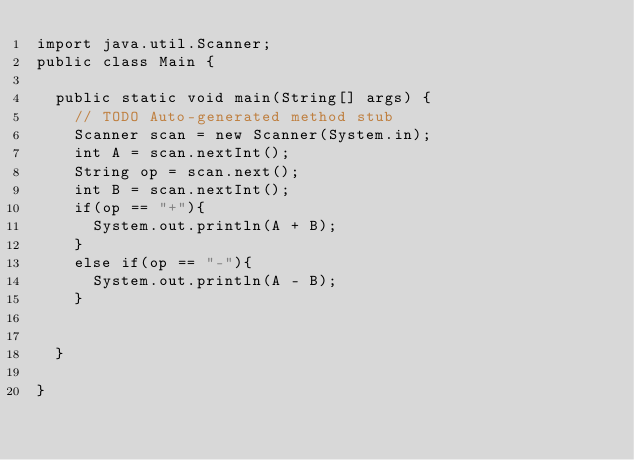<code> <loc_0><loc_0><loc_500><loc_500><_Java_>import java.util.Scanner;
public class Main {

	public static void main(String[] args) {
		// TODO Auto-generated method stub
		Scanner scan = new Scanner(System.in);
		int A = scan.nextInt();
		String op = scan.next();
		int B = scan.nextInt();
		if(op == "+"){
			System.out.println(A + B);
		}
		else if(op == "-"){
			System.out.println(A - B);
		}
		

	}

}
</code> 